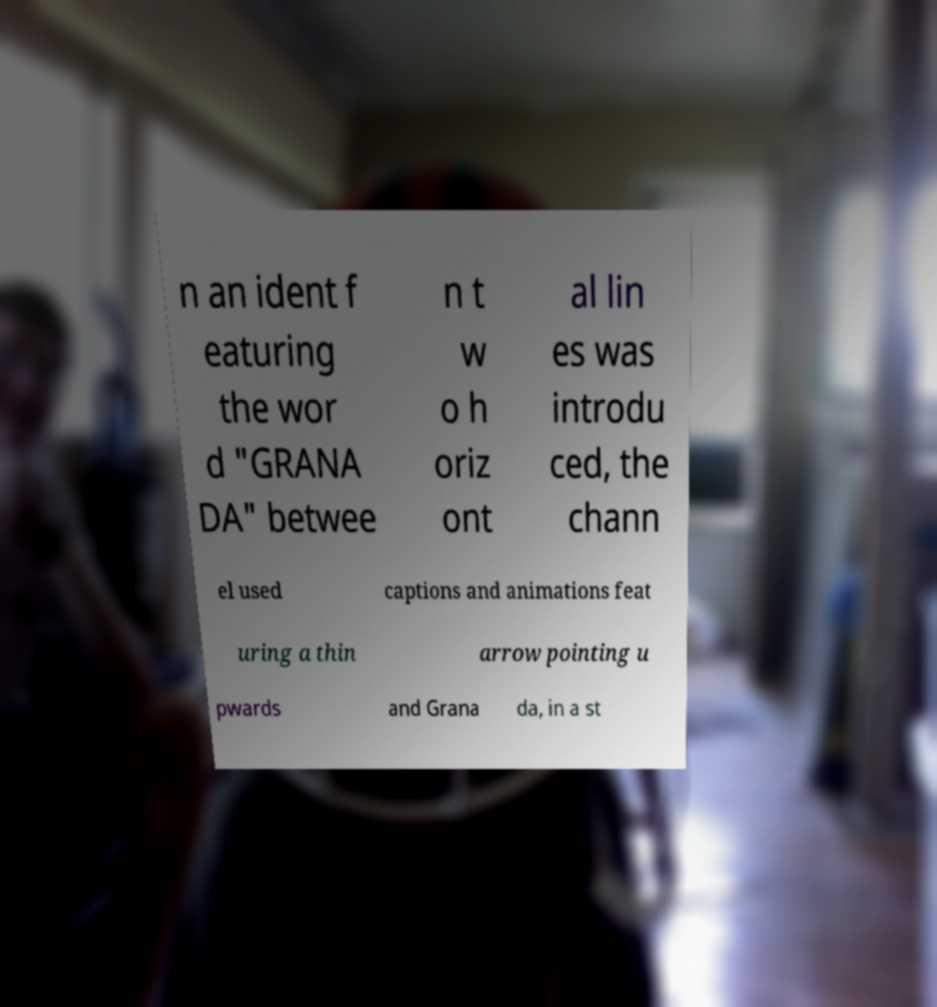Could you extract and type out the text from this image? n an ident f eaturing the wor d "GRANA DA" betwee n t w o h oriz ont al lin es was introdu ced, the chann el used captions and animations feat uring a thin arrow pointing u pwards and Grana da, in a st 